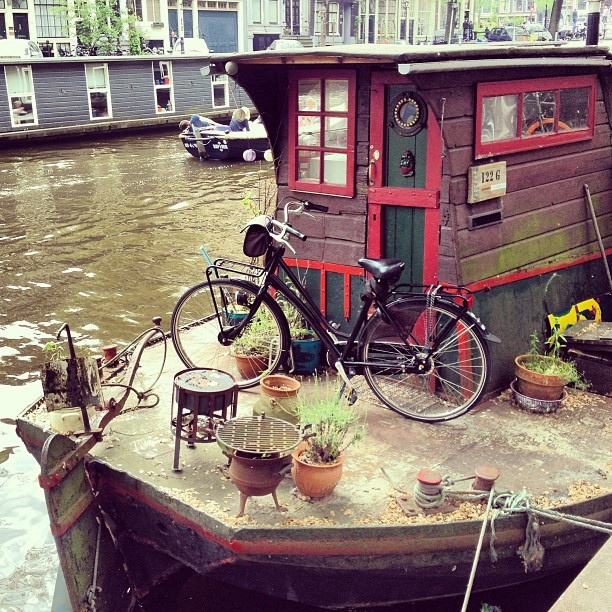Describe the objects in this image and their specific colors. I can see boat in gray, black, beige, and brown tones, bicycle in gray, black, beige, and darkgray tones, potted plant in gray, khaki, brown, and tan tones, potted plant in gray, beige, lightgreen, and darkgray tones, and boat in gray, black, ivory, and darkgray tones in this image. 